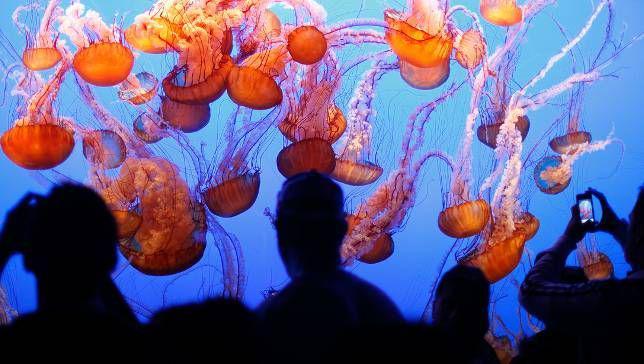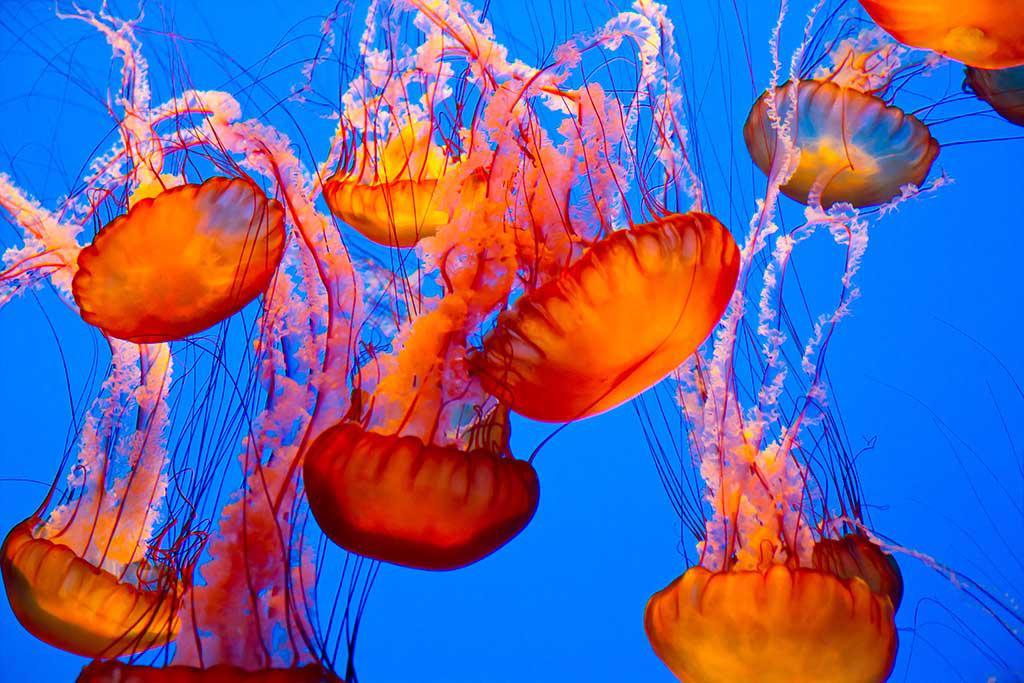The first image is the image on the left, the second image is the image on the right. Analyze the images presented: Is the assertion "There are deep red jellyfish and another with shadows of people" valid? Answer yes or no. Yes. The first image is the image on the left, the second image is the image on the right. Analyze the images presented: Is the assertion "Each image includes at least six orange jellyfish with long tendrils." valid? Answer yes or no. Yes. 